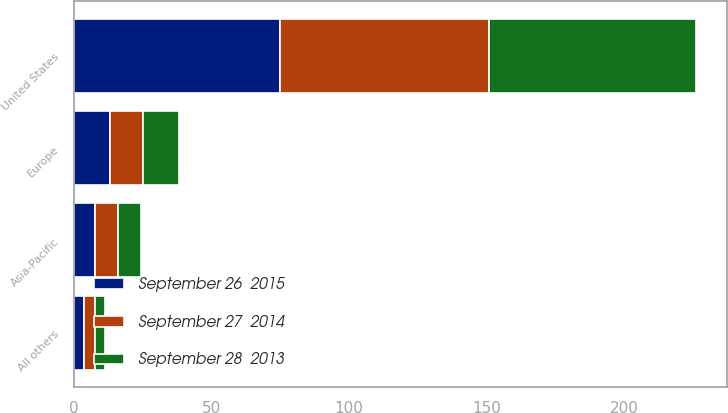<chart> <loc_0><loc_0><loc_500><loc_500><stacked_bar_chart><ecel><fcel>United States<fcel>Europe<fcel>Asia-Pacific<fcel>All others<nl><fcel>September 27  2014<fcel>76<fcel>11.8<fcel>8.5<fcel>3.7<nl><fcel>September 26  2015<fcel>75.1<fcel>13.3<fcel>7.7<fcel>3.9<nl><fcel>September 28  2013<fcel>74.9<fcel>13.2<fcel>8.1<fcel>3.8<nl></chart> 